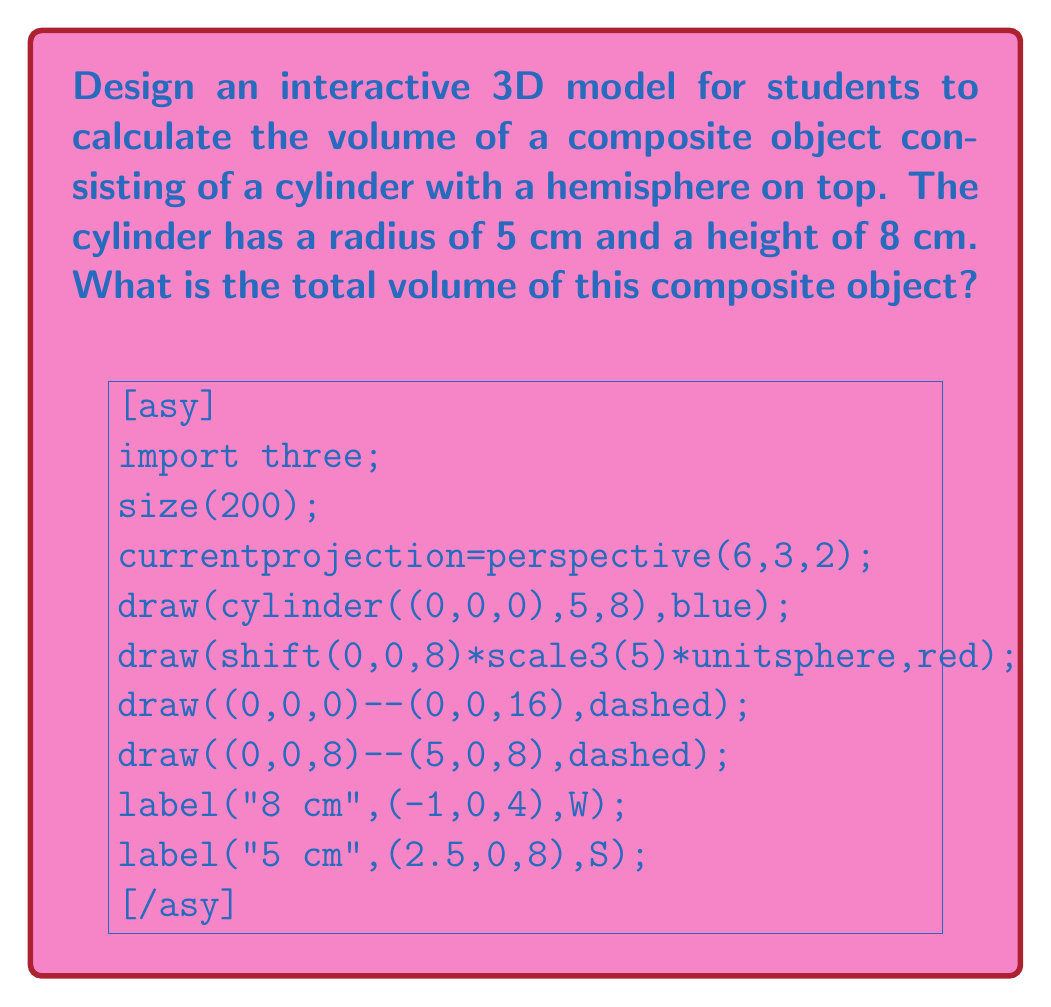Give your solution to this math problem. To find the total volume of this composite object, we need to calculate the volumes of both the cylinder and the hemisphere separately, then add them together.

1. Volume of the cylinder:
   The formula for the volume of a cylinder is $V_{cylinder} = \pi r^2 h$
   $$V_{cylinder} = \pi \cdot 5^2 \cdot 8 = 200\pi \text{ cm}^3$$

2. Volume of the hemisphere:
   The formula for the volume of a hemisphere is $V_{hemisphere} = \frac{2}{3}\pi r^3$
   $$V_{hemisphere} = \frac{2}{3}\pi \cdot 5^3 = \frac{250}{3}\pi \text{ cm}^3$$

3. Total volume:
   $$\begin{align}
   V_{total} &= V_{cylinder} + V_{hemisphere} \\
   &= 200\pi + \frac{250}{3}\pi \\
   &= \frac{600}{3}\pi + \frac{250}{3}\pi \\
   &= \frac{850}{3}\pi \text{ cm}^3
   \end{align}$$

Therefore, the total volume of the composite object is $\frac{850}{3}\pi \text{ cm}^3$ or approximately 889.78 cm³.
Answer: $\frac{850}{3}\pi \text{ cm}^3$ 